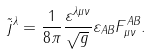<formula> <loc_0><loc_0><loc_500><loc_500>\tilde { j } ^ { \lambda } = \frac { 1 } { 8 \pi } \frac { \varepsilon ^ { \lambda \mu \nu } } { \sqrt { g } } \varepsilon _ { A B } F ^ { A B } _ { \mu \nu } .</formula> 